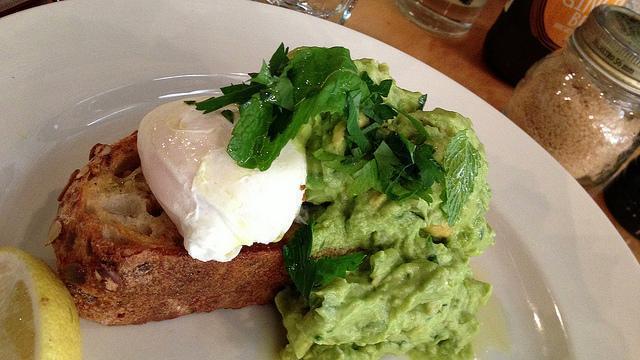What is the light green mixture?
Answer the question by selecting the correct answer among the 4 following choices and explain your choice with a short sentence. The answer should be formatted with the following format: `Answer: choice
Rationale: rationale.`
Options: Sauerkraut, salsa verde, guacamole, pesto. Answer: guacamole.
Rationale: The mixture is guacamole. 